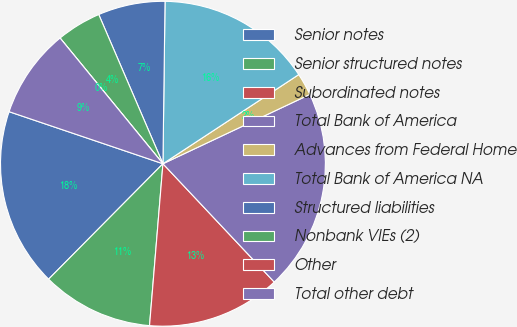Convert chart. <chart><loc_0><loc_0><loc_500><loc_500><pie_chart><fcel>Senior notes<fcel>Senior structured notes<fcel>Subordinated notes<fcel>Total Bank of America<fcel>Advances from Federal Home<fcel>Total Bank of America NA<fcel>Structured liabilities<fcel>Nonbank VIEs (2)<fcel>Other<fcel>Total other debt<nl><fcel>17.77%<fcel>11.11%<fcel>13.33%<fcel>20.0%<fcel>2.23%<fcel>15.55%<fcel>6.67%<fcel>4.45%<fcel>0.0%<fcel>8.89%<nl></chart> 